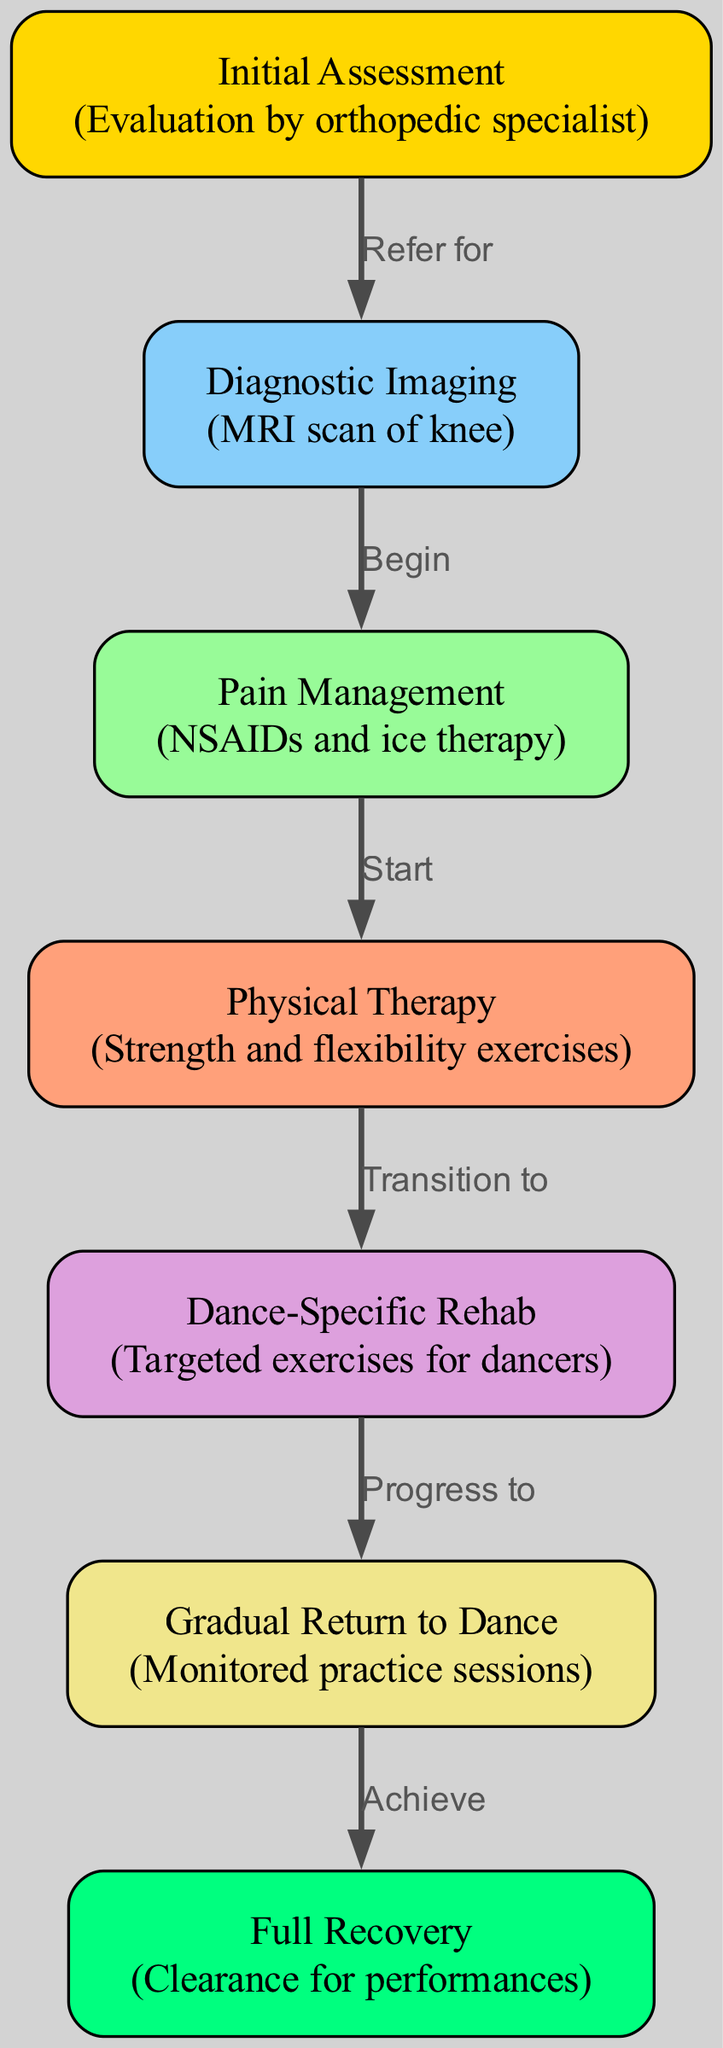What is the first step in the rehabilitation pathway? The first node in the diagram is 'Initial Assessment', which is labeled as 'Evaluation by orthopedic specialist'. This indicates that the initial action in the recovery process is the assessment conducted by the specialist.
Answer: Initial Assessment How many nodes are present in the diagram? By counting the 'nodes' listed in the data, we see there are 7 distinct nodes represented, each corresponding to different steps in the rehabilitation pathway.
Answer: 7 What does the "Diagnostic Imaging" step refer to? The node labeled 'Diagnostic Imaging' includes the detail 'MRI scan of knee', which specifies that this step involves conducting an MRI scan to further evaluate the knee injury.
Answer: MRI scan of knee What follows the "Pain Management" step? The diagram indicates that after the 'Pain Management' node, which involves 'NSAIDs and ice therapy', the next step is 'Physical Therapy', demonstrating a progression from managing pain to beginning physical rehabilitation.
Answer: Physical Therapy Which step is directly related to dancers specifically? The step 'Dance-Specific Rehab' is specifically tailored for dancers and focuses on targeted exercises designed for their rehabilitation needs, distinguishing it from general rehabilitation.
Answer: Dance-Specific Rehab What is the last step in the rehabilitation pathway? The final node in the diagram is labeled 'Full Recovery', which signifies the endpoint of the rehabilitation process where clearance for performances is achieved.
Answer: Full Recovery How many edges are connecting the nodes in the diagram? By examining the 'edges' data, we can identify that there are 6 connections between the 7 nodes, which illustrate the relationships and flow of the rehabilitation process.
Answer: 6 What is the transition from "Physical Therapy" to "Dance-Specific Rehab"? The diagram shows that the transition from the 'Physical Therapy' node leads to 'Dance-Specific Rehab', indicating a progression from general physical therapy exercises to those specific to dancers’ needs.
Answer: Transition to Dance-Specific Rehab What is achieved after the "Gradual Return to Dance"? From the diagram, it's illustrated that the step following 'Gradual Return to Dance' leads to 'Full Recovery', which indicates that the goal of this gradual return is to ultimately achieve complete recovery.
Answer: Achieve Full Recovery 